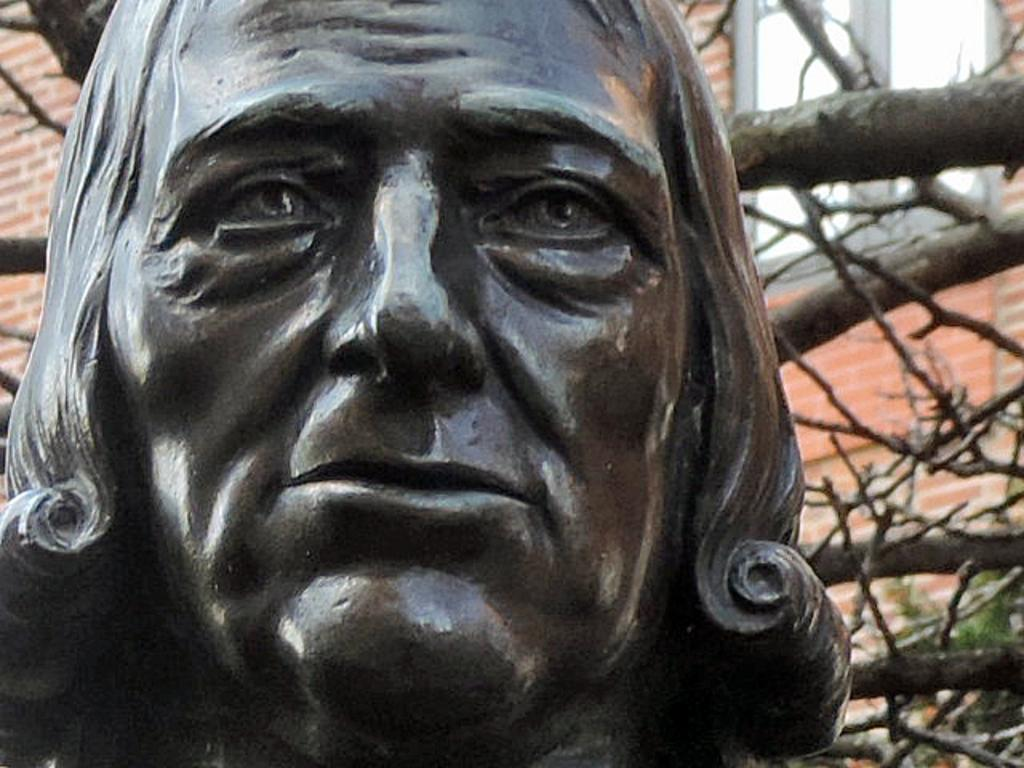What is the main subject of the image? There is a sculpture in the image. What can be seen in the background of the image? There are branches and a wall in the background of the image. Is there any opening in the wall visible in the image? Yes, there is a window in the background of the image. What type of chicken is sitting on the sculpture in the image? There is no chicken present in the image; it features a sculpture and a background with branches and a wall. 